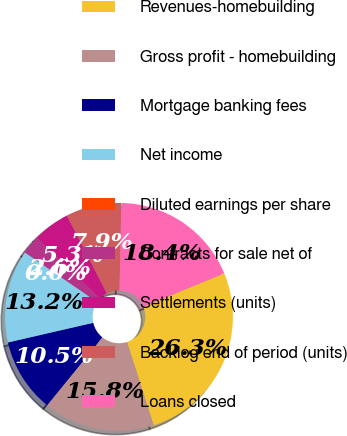<chart> <loc_0><loc_0><loc_500><loc_500><pie_chart><fcel>Revenues-homebuilding<fcel>Gross profit - homebuilding<fcel>Mortgage banking fees<fcel>Net income<fcel>Diluted earnings per share<fcel>Contracts for sale net of<fcel>Settlements (units)<fcel>Backlog end of period (units)<fcel>Loans closed<nl><fcel>26.32%<fcel>15.79%<fcel>10.53%<fcel>13.16%<fcel>0.0%<fcel>2.63%<fcel>5.26%<fcel>7.89%<fcel>18.42%<nl></chart> 